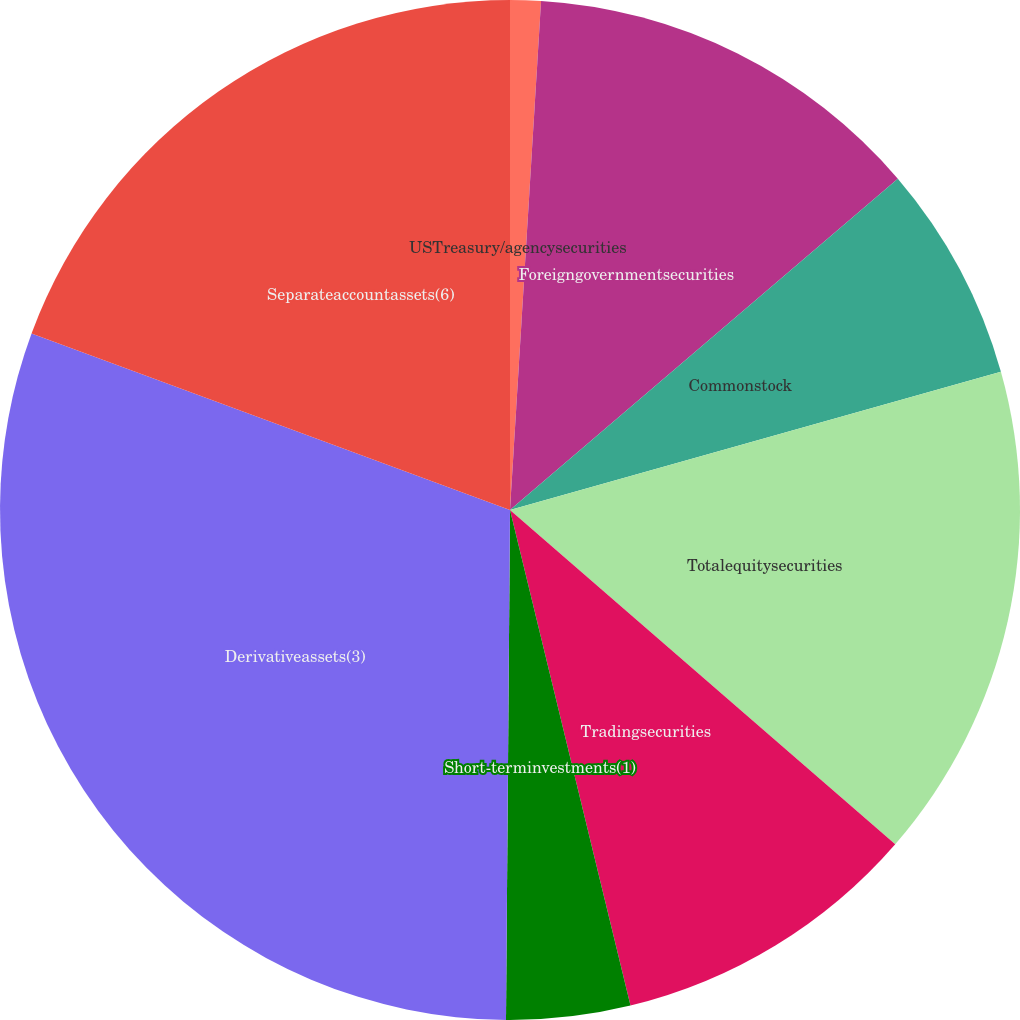Convert chart. <chart><loc_0><loc_0><loc_500><loc_500><pie_chart><fcel>USTreasury/agencysecurities<fcel>Foreigngovernmentsecurities<fcel>Commonstock<fcel>Totalequitysecurities<fcel>Tradingsecurities<fcel>Short-terminvestments(1)<fcel>Derivativeassets(3)<fcel>Separateaccountassets(6)<nl><fcel>0.97%<fcel>12.78%<fcel>6.88%<fcel>15.74%<fcel>9.83%<fcel>3.92%<fcel>30.5%<fcel>19.37%<nl></chart> 